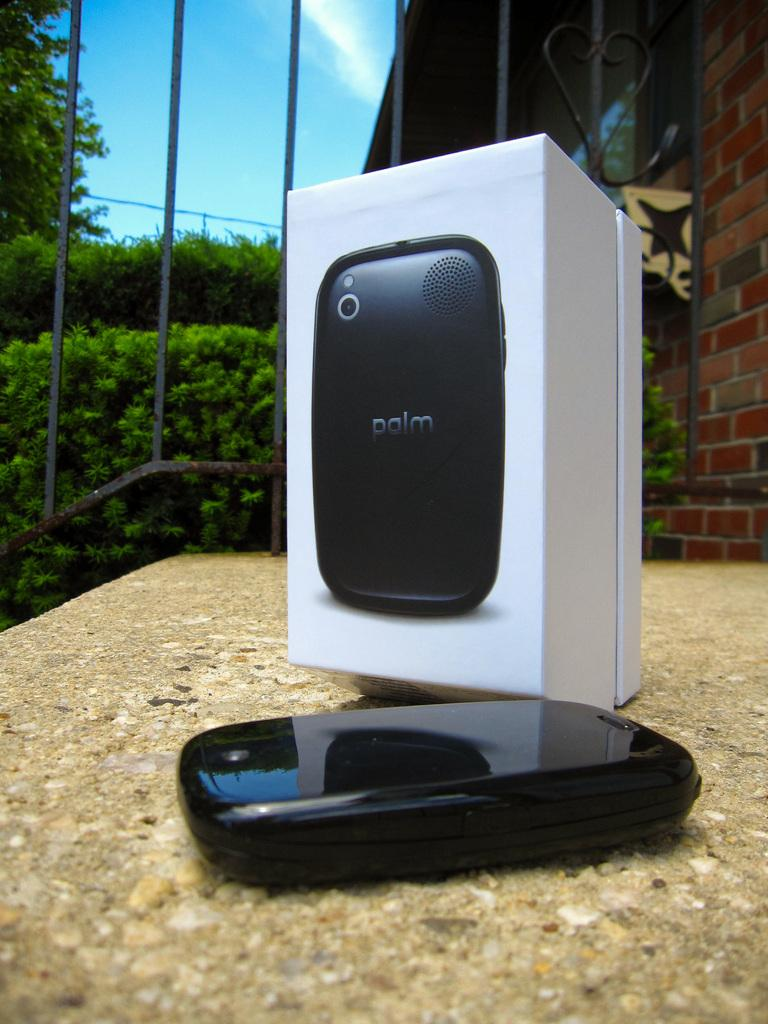<image>
Create a compact narrative representing the image presented. Palm pilot box and pilot palm sitting on partical board table outside in a yard. 